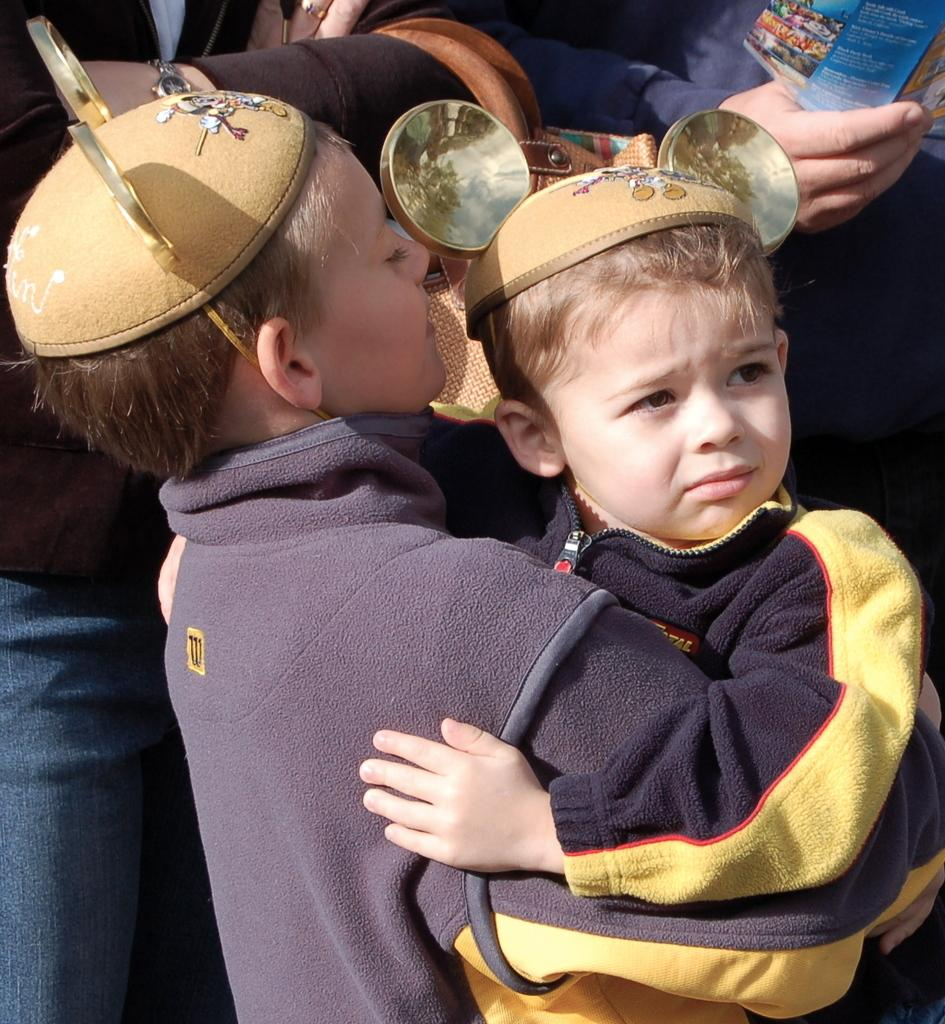How many people are in the image? There are people in the image, but the exact number is not specified. What are the kids wearing on their heads? Two kids are wearing caps. How many oranges are on the bike in the image? There is no bike or oranges present in the image. What color is the spot on the kid's shirt in the image? There is no mention of a spot on any kid's shirt in the image. 